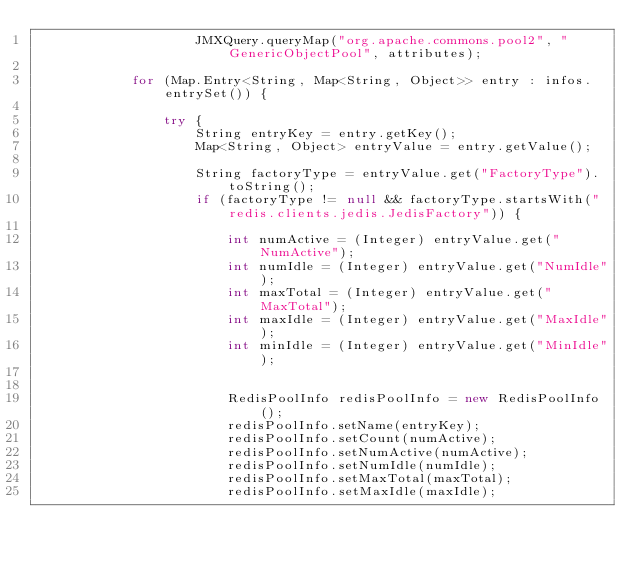Convert code to text. <code><loc_0><loc_0><loc_500><loc_500><_Java_>                    JMXQuery.queryMap("org.apache.commons.pool2", "GenericObjectPool", attributes);

            for (Map.Entry<String, Map<String, Object>> entry : infos.entrySet()) {

                try {
                    String entryKey = entry.getKey();
                    Map<String, Object> entryValue = entry.getValue();

                    String factoryType = entryValue.get("FactoryType").toString();
                    if (factoryType != null && factoryType.startsWith("redis.clients.jedis.JedisFactory")) {

                        int numActive = (Integer) entryValue.get("NumActive");
                        int numIdle = (Integer) entryValue.get("NumIdle");
                        int maxTotal = (Integer) entryValue.get("MaxTotal");
                        int maxIdle = (Integer) entryValue.get("MaxIdle");
                        int minIdle = (Integer) entryValue.get("MinIdle");


                        RedisPoolInfo redisPoolInfo = new RedisPoolInfo();
                        redisPoolInfo.setName(entryKey);
                        redisPoolInfo.setCount(numActive);
                        redisPoolInfo.setNumActive(numActive);
                        redisPoolInfo.setNumIdle(numIdle);
                        redisPoolInfo.setMaxTotal(maxTotal);
                        redisPoolInfo.setMaxIdle(maxIdle);</code> 